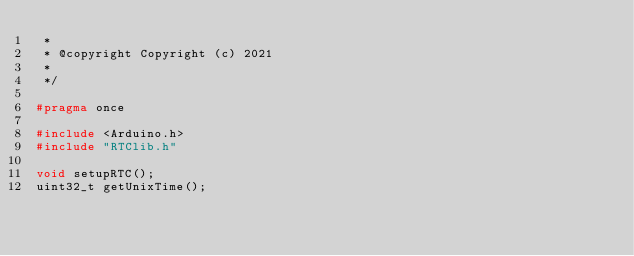Convert code to text. <code><loc_0><loc_0><loc_500><loc_500><_C++_> *
 * @copyright Copyright (c) 2021
 *
 */

#pragma once

#include <Arduino.h>
#include "RTClib.h"

void setupRTC();
uint32_t getUnixTime();
</code> 